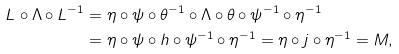<formula> <loc_0><loc_0><loc_500><loc_500>L \circ \Lambda \circ L ^ { - 1 } & = \eta \circ \psi \circ \theta ^ { - 1 } \circ \Lambda \circ \theta \circ \psi ^ { - 1 } \circ \eta ^ { - 1 } \\ & = \eta \circ \psi \circ h \circ \psi ^ { - 1 } \circ \eta ^ { - 1 } = \eta \circ j \circ \eta ^ { - 1 } = M ,</formula> 